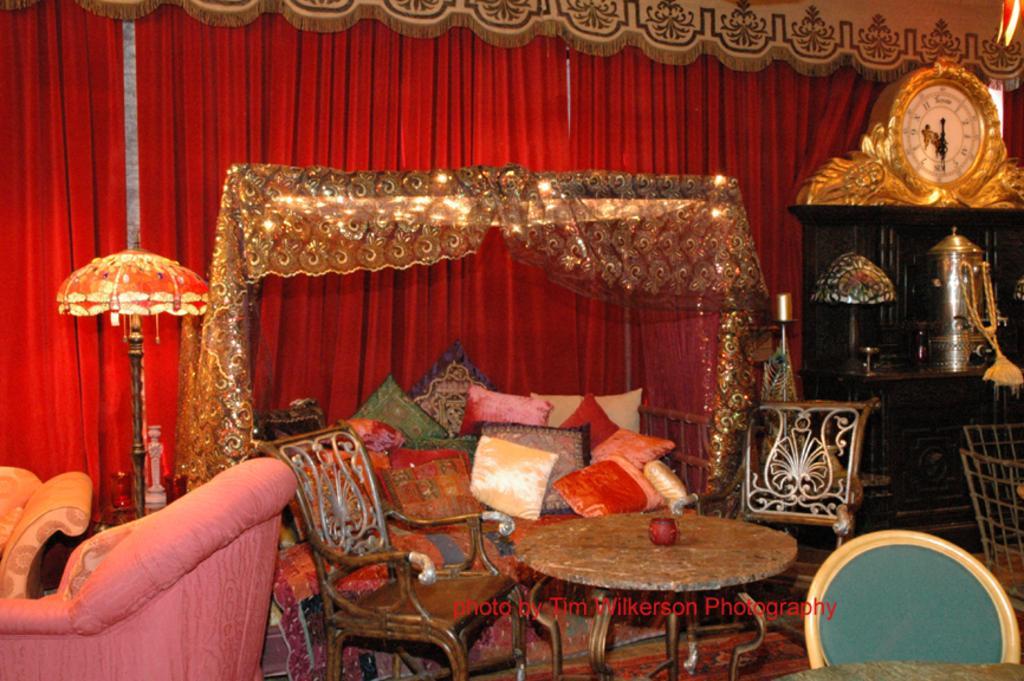Could you give a brief overview of what you see in this image? In this picture there is a table and chairs at the bottom side of the image and there is sofa in the bottom left side of the image and there is a showcase on the right side of the image, there is a bed in the center of the image, on which there are pillows and there is black color curtain in the background area of the image. 